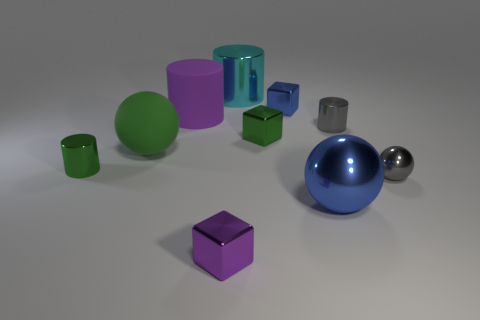Can you tell me what the different objects in this image represent if we were to imagine them as a family? In a whimsical interpretation, the largest green cylinder could represent a parent figure due to its size and central placement. The blue spherical object could be seen as the other parent with a reflective and vibrant presence. The smaller objects, including the cubes and smaller cylinders, could be thought of as children, each with their own unique shape and color, indicating different personalities within this 'family'. The matte ball might represent a pet or a family friend, given its distinct texture and separate location. 